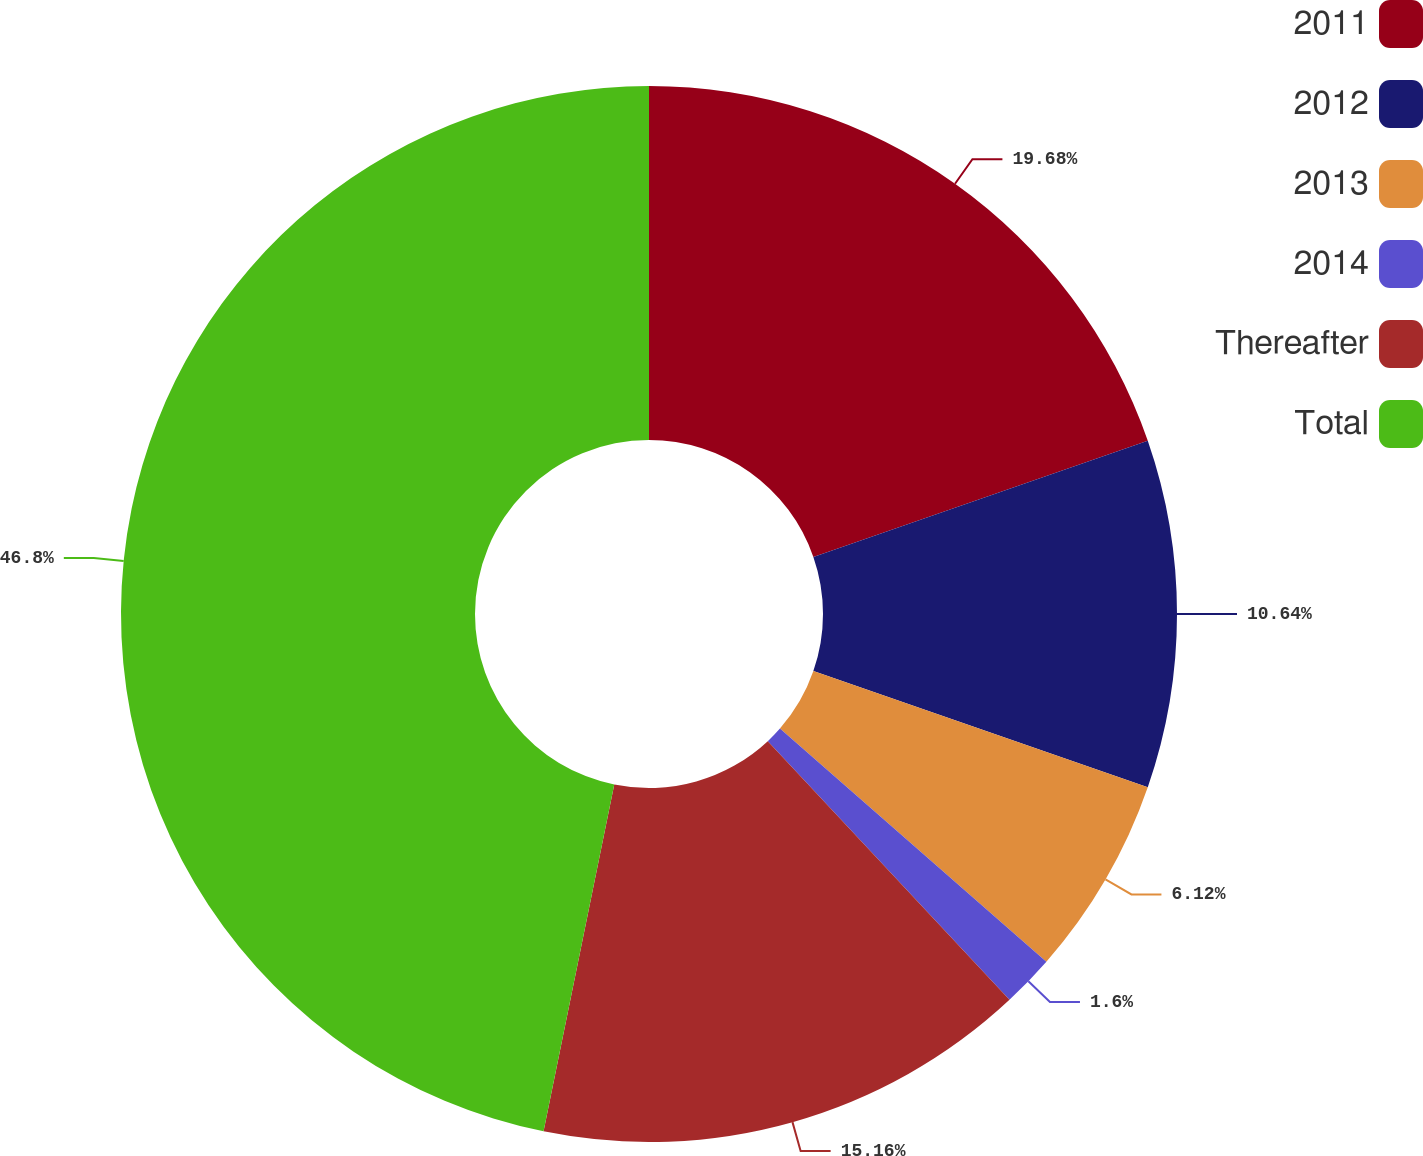Convert chart to OTSL. <chart><loc_0><loc_0><loc_500><loc_500><pie_chart><fcel>2011<fcel>2012<fcel>2013<fcel>2014<fcel>Thereafter<fcel>Total<nl><fcel>19.68%<fcel>10.64%<fcel>6.12%<fcel>1.6%<fcel>15.16%<fcel>46.8%<nl></chart> 